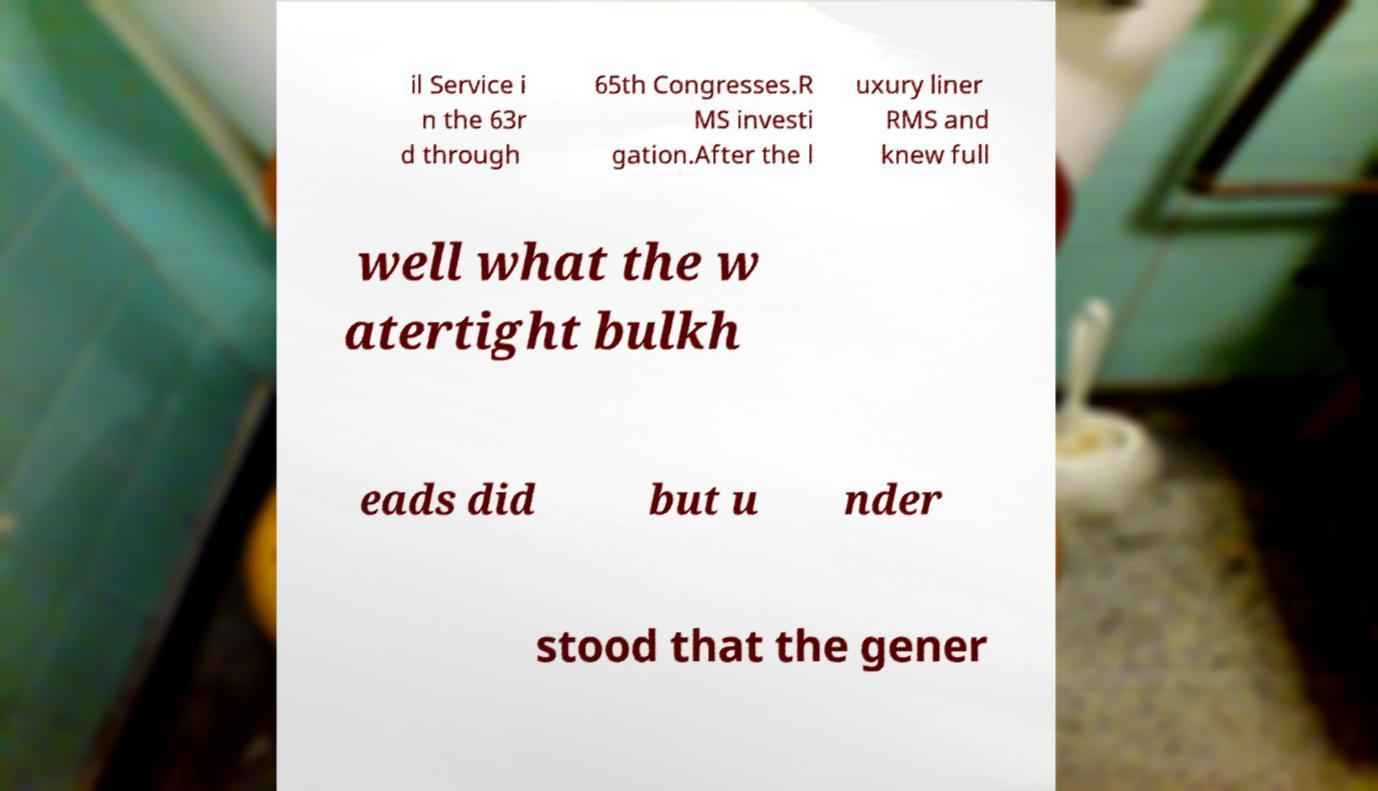Could you extract and type out the text from this image? il Service i n the 63r d through 65th Congresses.R MS investi gation.After the l uxury liner RMS and knew full well what the w atertight bulkh eads did but u nder stood that the gener 